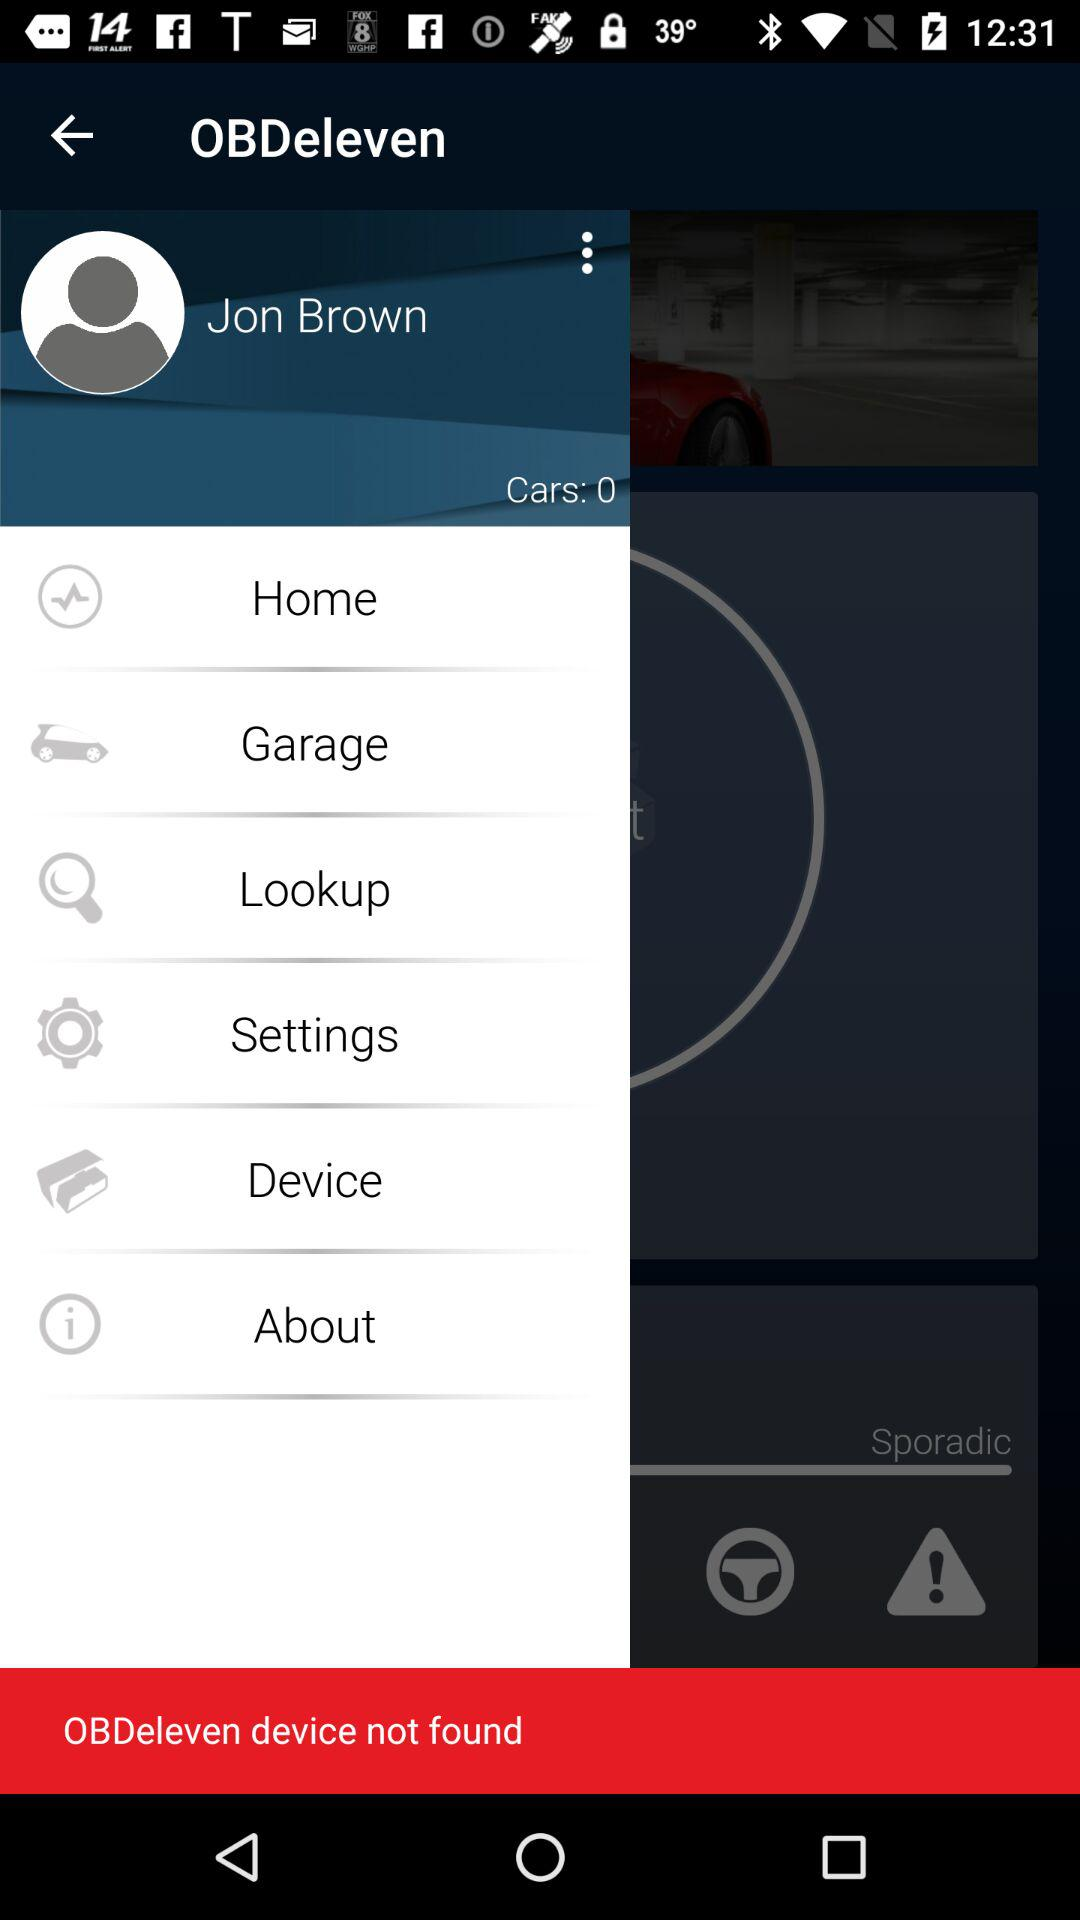What is the user name? The user name is Jon Brown. 